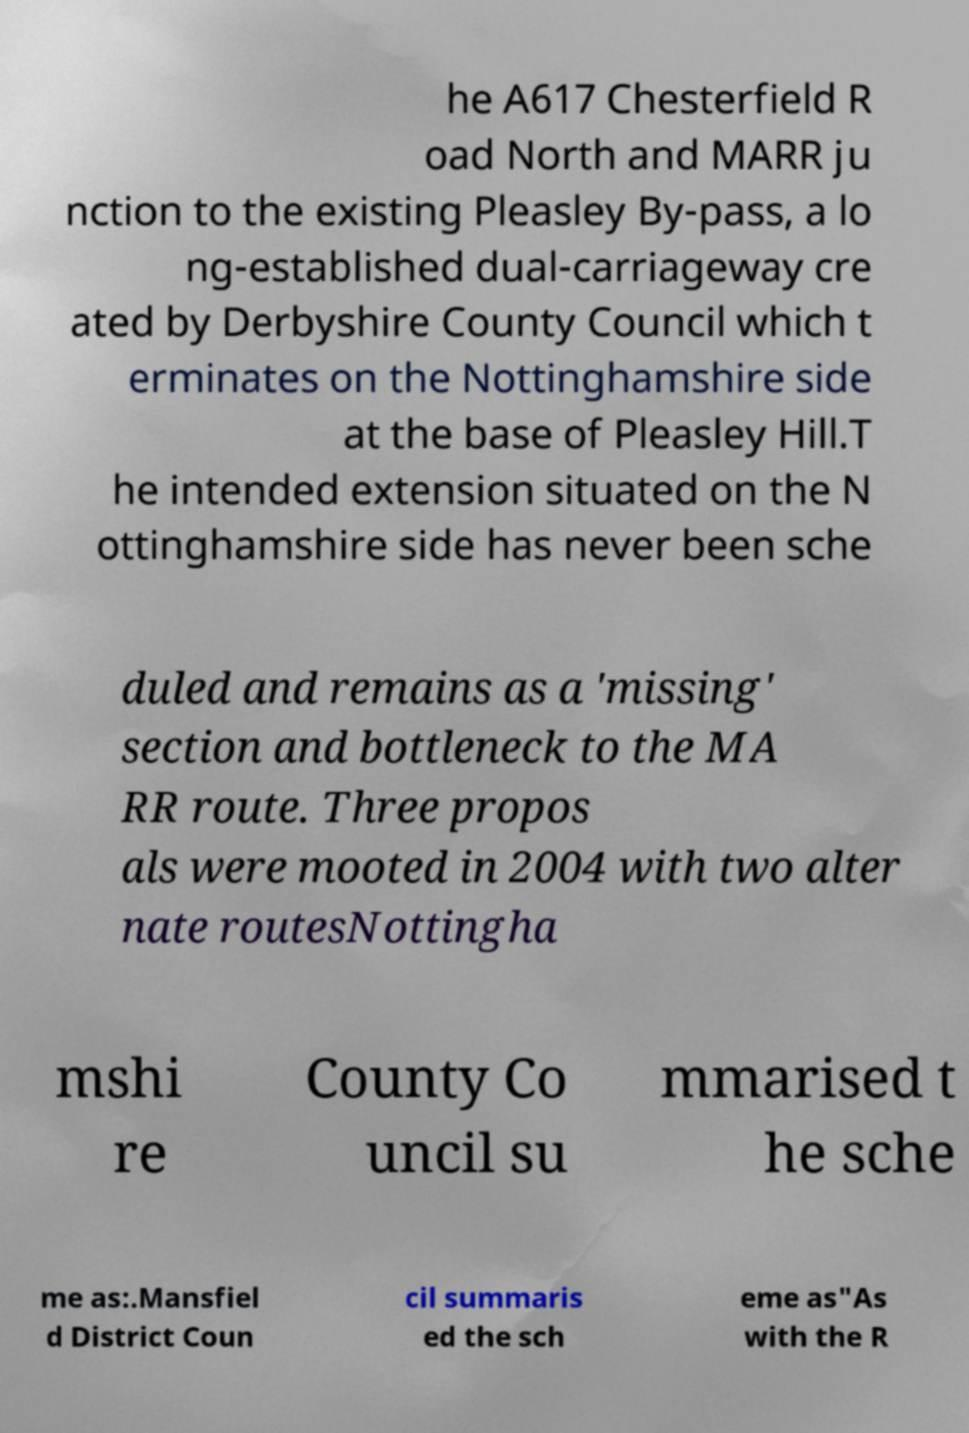For documentation purposes, I need the text within this image transcribed. Could you provide that? he A617 Chesterfield R oad North and MARR ju nction to the existing Pleasley By-pass, a lo ng-established dual-carriageway cre ated by Derbyshire County Council which t erminates on the Nottinghamshire side at the base of Pleasley Hill.T he intended extension situated on the N ottinghamshire side has never been sche duled and remains as a 'missing' section and bottleneck to the MA RR route. Three propos als were mooted in 2004 with two alter nate routesNottingha mshi re County Co uncil su mmarised t he sche me as:.Mansfiel d District Coun cil summaris ed the sch eme as"As with the R 